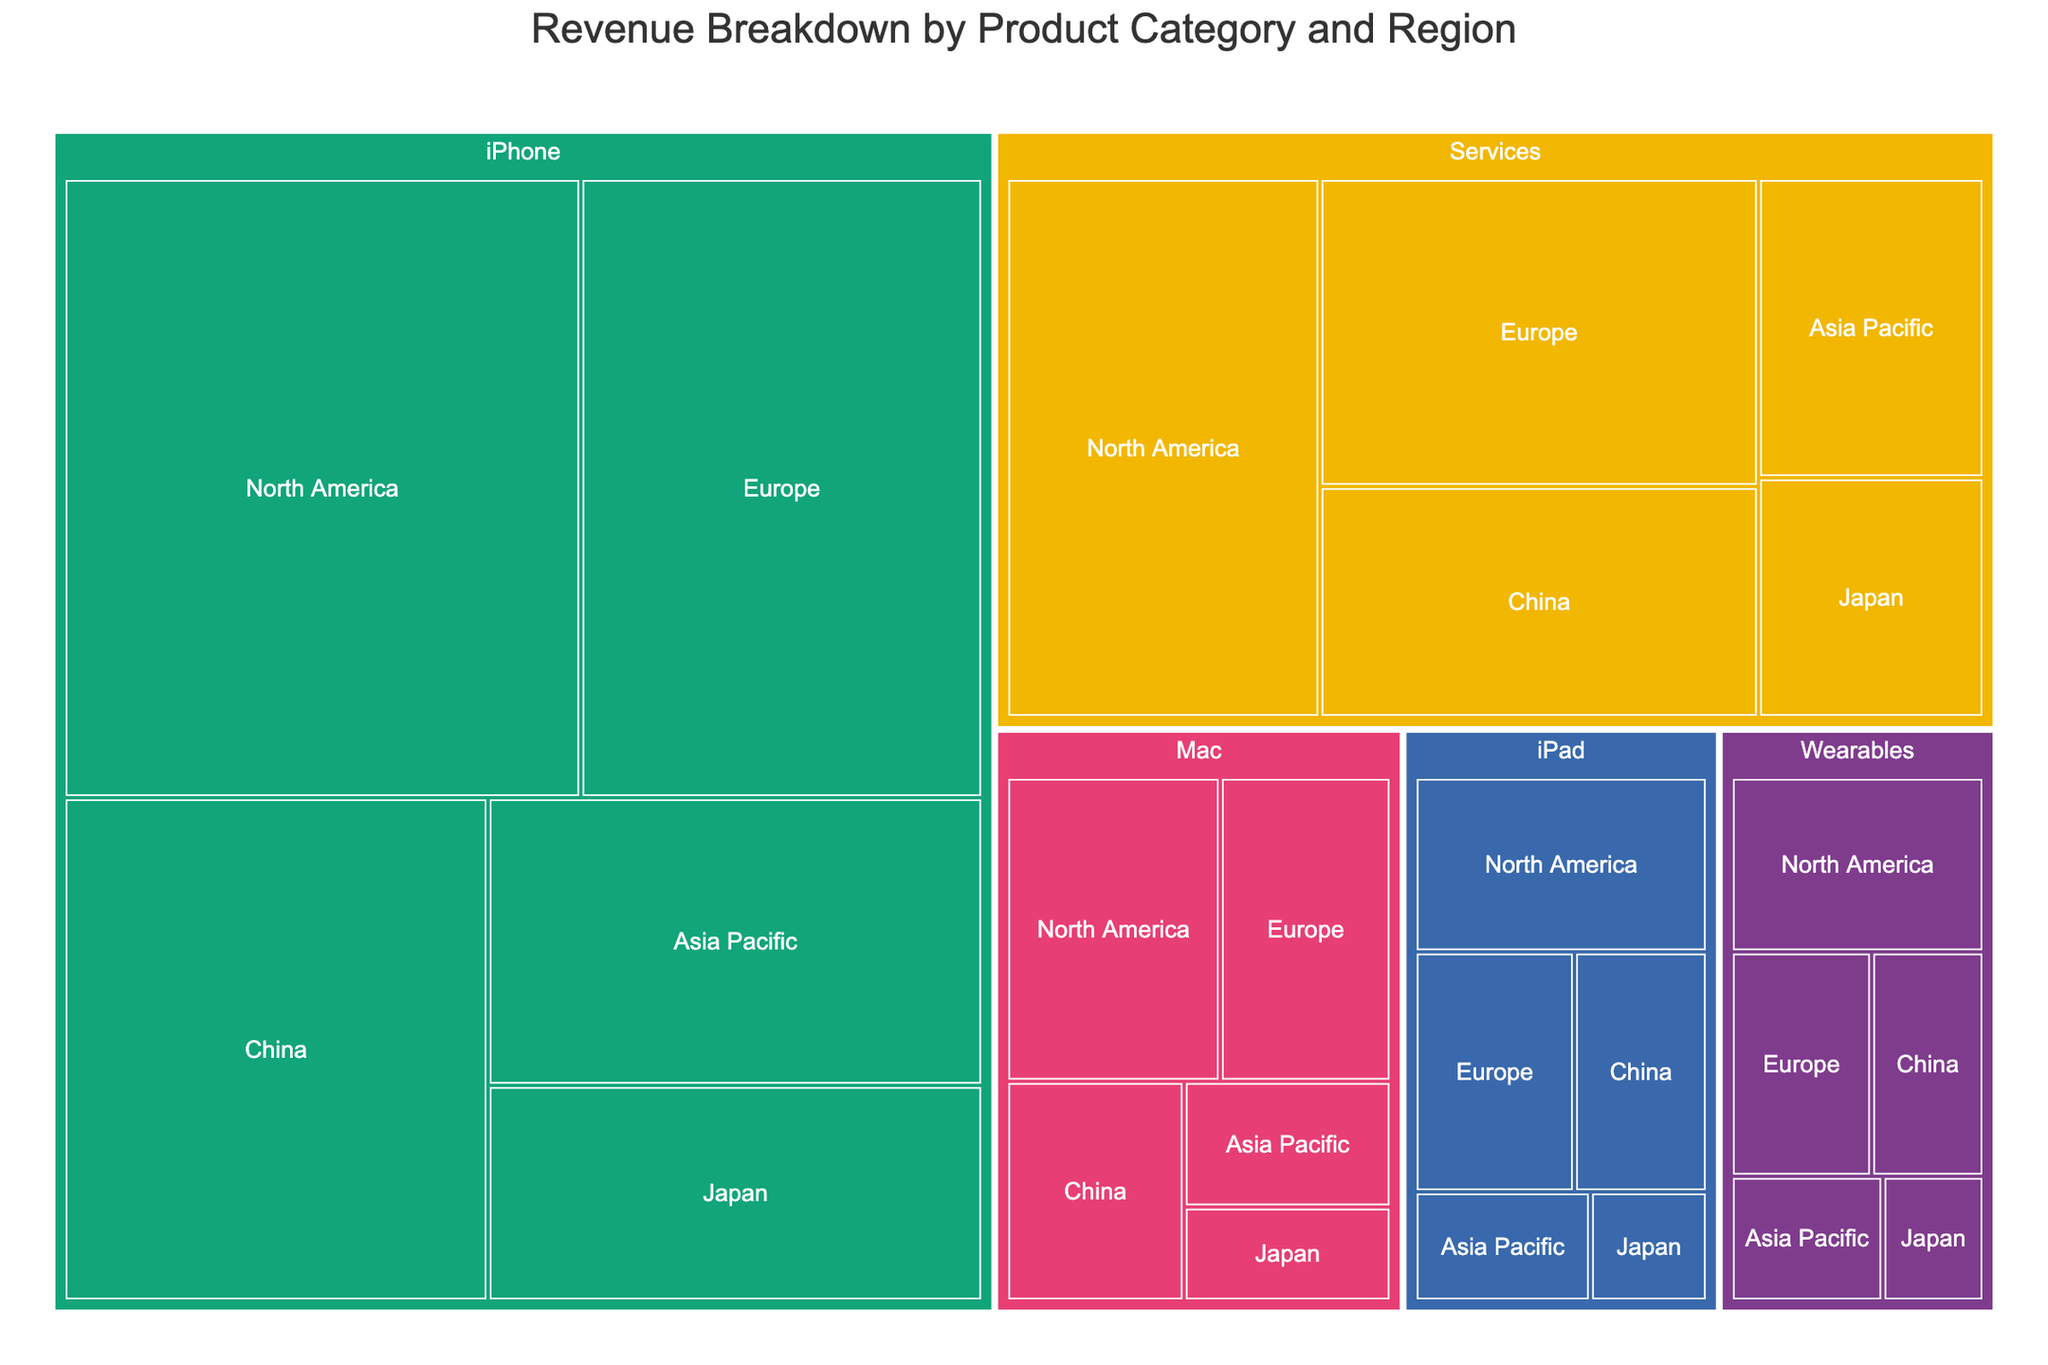What is the title of the figure? The title is usually displayed at the top of the figure. Here, it reads 'Revenue Breakdown by Product Category and Region'.
Answer: Revenue Breakdown by Product Category and Region Which product category generates the most revenue in North America? To answer this, look for the largest segment labeled 'North America' in the respective product categories. The iPhone category has the largest revenue in North America.
Answer: iPhone What is the combined revenue from iPads in Japan and China? Find the segments for iPads in Japan and China, which show revenues of $2,000,000,000 and $5,000,000,000 respectively. Summing these up gives $7,000,000,000.
Answer: $7,000,000,000 How does the revenue from Wearables in Europe compare to that in China? Identify the segments for Wearables in Europe and China. Europe has $5,000,000,000 while China has $4,000,000,000. Europe’s revenue is higher.
Answer: Europe has more revenue What product category has the smallest revenue in Asia Pacific? Examine the segments in Asia Pacific for the smallest segment. The Wearables segment in Asia Pacific has the smallest revenue.
Answer: Wearables What is the total revenue from the Services product category across all regions? Sum up the revenues from Services in North America ($25,000,000,000), Europe ($20,000,000,000), China ($15,000,000,000), Asia Pacific ($10,000,000,000), and Japan ($8,000,000,000). Total is $78,000,000,000.
Answer: $78,000,000,000 Which region contributes the most revenue for Mac products? Check the segments for Mac products across all regions. North America, with $10,000,000,000, contributes the most revenue.
Answer: North America How does the revenue from iPhones in China compare to the revenue from Mac products in North America? Compare the segments: iPhones in China have $30,000,000,000 whereas Mac in North America has $10,000,000,000. iPhone revenue in China is greater.
Answer: Greater What is the average revenue from Mac products across the different regions? Sum the revenues from Mac across all regions (North America: $10,000,000,000, Europe: $8,000,000,000, China: $6,000,000,000, Asia Pacific: $4,000,000,000, Japan: $3,000,000,000) to get $31,000,000,000. Average by dividing by 5: $31,000,000,000 / 5 = $6,200,000,000.
Answer: $6,200,000,000 Which product category has the most diverse spread of revenue across different regions? Look for a product category with sizable segments across various regions. The Services category has a high revenue spread across North America, Europe, China, Asia Pacific, and Japan.
Answer: Services 